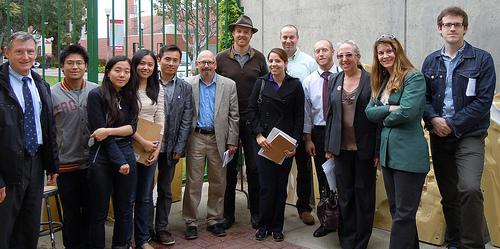Question: where are the people standing?
Choices:
A. On the grass.
B. In a boat.
C. By a car.
D. On a patio outside.
Answer with the letter. Answer: D Question: how many people are wearing glasses?
Choices:
A. Three.
B. Two.
C. Four.
D. Five.
Answer with the letter. Answer: B Question: who is wearing a hat?
Choices:
A. The child is.
B. The clown.
C. The baseball player.
D. The tall man in the middle.
Answer with the letter. Answer: D Question: how many women?
Choices:
A. Six.
B. Seven.
C. Eight.
D. Five.
Answer with the letter. Answer: D Question: what kind of jacket is the man on the right wearing?
Choices:
A. Leather jacket.
B. Rain jacket.
C. Jeans jacket.
D. Black Jacket.
Answer with the letter. Answer: C Question: what color hair does the man on the left have?
Choices:
A. Red.
B. Blue.
C. Green.
D. Grey.
Answer with the letter. Answer: D 